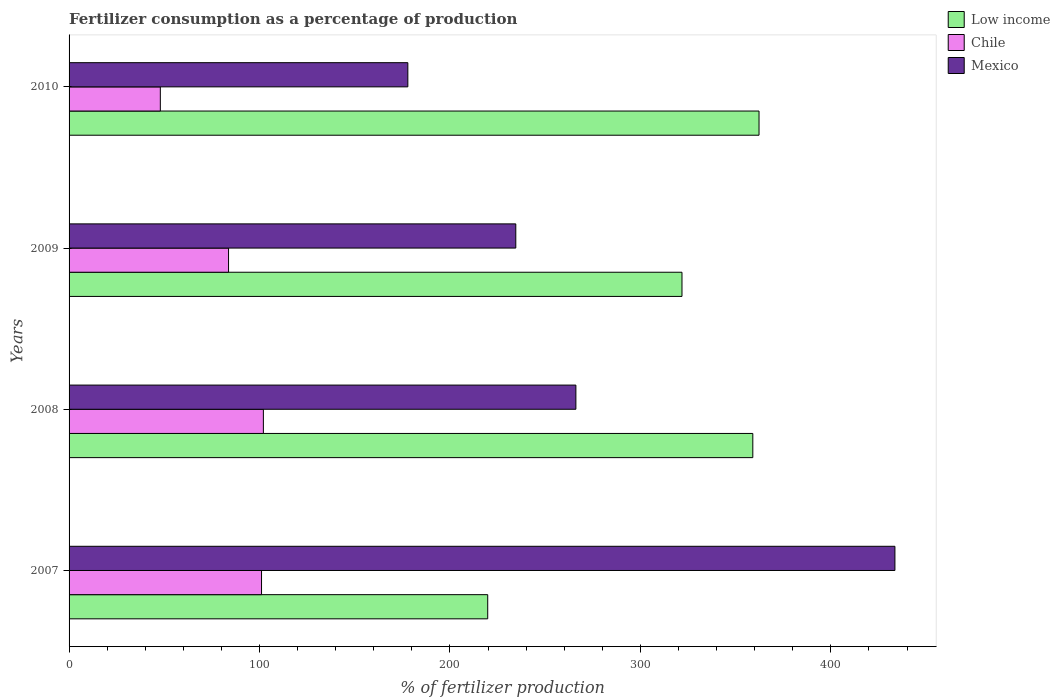How many different coloured bars are there?
Your answer should be very brief. 3. Are the number of bars per tick equal to the number of legend labels?
Provide a succinct answer. Yes. How many bars are there on the 2nd tick from the top?
Keep it short and to the point. 3. In how many cases, is the number of bars for a given year not equal to the number of legend labels?
Your answer should be very brief. 0. What is the percentage of fertilizers consumed in Mexico in 2008?
Provide a succinct answer. 266.11. Across all years, what is the maximum percentage of fertilizers consumed in Mexico?
Give a very brief answer. 433.62. Across all years, what is the minimum percentage of fertilizers consumed in Chile?
Make the answer very short. 47.92. In which year was the percentage of fertilizers consumed in Low income minimum?
Ensure brevity in your answer.  2007. What is the total percentage of fertilizers consumed in Chile in the graph?
Provide a short and direct response. 334.73. What is the difference between the percentage of fertilizers consumed in Low income in 2009 and that in 2010?
Your response must be concise. -40.45. What is the difference between the percentage of fertilizers consumed in Mexico in 2009 and the percentage of fertilizers consumed in Low income in 2008?
Your response must be concise. -124.45. What is the average percentage of fertilizers consumed in Low income per year?
Your answer should be compact. 315.73. In the year 2008, what is the difference between the percentage of fertilizers consumed in Chile and percentage of fertilizers consumed in Mexico?
Your response must be concise. -164.09. In how many years, is the percentage of fertilizers consumed in Low income greater than 180 %?
Provide a short and direct response. 4. What is the ratio of the percentage of fertilizers consumed in Chile in 2007 to that in 2009?
Provide a succinct answer. 1.21. Is the difference between the percentage of fertilizers consumed in Chile in 2007 and 2009 greater than the difference between the percentage of fertilizers consumed in Mexico in 2007 and 2009?
Ensure brevity in your answer.  No. What is the difference between the highest and the second highest percentage of fertilizers consumed in Low income?
Your answer should be very brief. 3.26. What is the difference between the highest and the lowest percentage of fertilizers consumed in Low income?
Your response must be concise. 142.46. Is the sum of the percentage of fertilizers consumed in Chile in 2008 and 2009 greater than the maximum percentage of fertilizers consumed in Mexico across all years?
Your answer should be compact. No. What does the 3rd bar from the bottom in 2007 represents?
Keep it short and to the point. Mexico. How many bars are there?
Keep it short and to the point. 12. Are the values on the major ticks of X-axis written in scientific E-notation?
Make the answer very short. No. Does the graph contain any zero values?
Your answer should be very brief. No. How many legend labels are there?
Your answer should be very brief. 3. How are the legend labels stacked?
Offer a very short reply. Vertical. What is the title of the graph?
Your response must be concise. Fertilizer consumption as a percentage of production. What is the label or title of the X-axis?
Keep it short and to the point. % of fertilizer production. What is the % of fertilizer production of Low income in 2007?
Your answer should be compact. 219.81. What is the % of fertilizer production of Chile in 2007?
Keep it short and to the point. 101.06. What is the % of fertilizer production of Mexico in 2007?
Keep it short and to the point. 433.62. What is the % of fertilizer production of Low income in 2008?
Give a very brief answer. 359.01. What is the % of fertilizer production in Chile in 2008?
Offer a terse response. 102.02. What is the % of fertilizer production in Mexico in 2008?
Give a very brief answer. 266.11. What is the % of fertilizer production of Low income in 2009?
Keep it short and to the point. 321.82. What is the % of fertilizer production in Chile in 2009?
Keep it short and to the point. 83.73. What is the % of fertilizer production of Mexico in 2009?
Your answer should be compact. 234.56. What is the % of fertilizer production of Low income in 2010?
Provide a short and direct response. 362.27. What is the % of fertilizer production of Chile in 2010?
Provide a short and direct response. 47.92. What is the % of fertilizer production of Mexico in 2010?
Give a very brief answer. 177.87. Across all years, what is the maximum % of fertilizer production in Low income?
Give a very brief answer. 362.27. Across all years, what is the maximum % of fertilizer production of Chile?
Offer a terse response. 102.02. Across all years, what is the maximum % of fertilizer production of Mexico?
Keep it short and to the point. 433.62. Across all years, what is the minimum % of fertilizer production of Low income?
Your response must be concise. 219.81. Across all years, what is the minimum % of fertilizer production in Chile?
Keep it short and to the point. 47.92. Across all years, what is the minimum % of fertilizer production of Mexico?
Your answer should be compact. 177.87. What is the total % of fertilizer production in Low income in the graph?
Offer a very short reply. 1262.91. What is the total % of fertilizer production of Chile in the graph?
Ensure brevity in your answer.  334.73. What is the total % of fertilizer production in Mexico in the graph?
Provide a short and direct response. 1112.17. What is the difference between the % of fertilizer production in Low income in 2007 and that in 2008?
Give a very brief answer. -139.19. What is the difference between the % of fertilizer production in Chile in 2007 and that in 2008?
Provide a succinct answer. -0.96. What is the difference between the % of fertilizer production of Mexico in 2007 and that in 2008?
Keep it short and to the point. 167.51. What is the difference between the % of fertilizer production of Low income in 2007 and that in 2009?
Make the answer very short. -102.01. What is the difference between the % of fertilizer production of Chile in 2007 and that in 2009?
Your answer should be very brief. 17.32. What is the difference between the % of fertilizer production in Mexico in 2007 and that in 2009?
Make the answer very short. 199.06. What is the difference between the % of fertilizer production in Low income in 2007 and that in 2010?
Your response must be concise. -142.46. What is the difference between the % of fertilizer production of Chile in 2007 and that in 2010?
Give a very brief answer. 53.14. What is the difference between the % of fertilizer production of Mexico in 2007 and that in 2010?
Ensure brevity in your answer.  255.75. What is the difference between the % of fertilizer production in Low income in 2008 and that in 2009?
Keep it short and to the point. 37.19. What is the difference between the % of fertilizer production in Chile in 2008 and that in 2009?
Your response must be concise. 18.29. What is the difference between the % of fertilizer production of Mexico in 2008 and that in 2009?
Provide a short and direct response. 31.56. What is the difference between the % of fertilizer production in Low income in 2008 and that in 2010?
Offer a terse response. -3.26. What is the difference between the % of fertilizer production in Chile in 2008 and that in 2010?
Give a very brief answer. 54.1. What is the difference between the % of fertilizer production in Mexico in 2008 and that in 2010?
Your answer should be very brief. 88.24. What is the difference between the % of fertilizer production in Low income in 2009 and that in 2010?
Your answer should be compact. -40.45. What is the difference between the % of fertilizer production in Chile in 2009 and that in 2010?
Make the answer very short. 35.81. What is the difference between the % of fertilizer production in Mexico in 2009 and that in 2010?
Keep it short and to the point. 56.68. What is the difference between the % of fertilizer production of Low income in 2007 and the % of fertilizer production of Chile in 2008?
Your answer should be very brief. 117.79. What is the difference between the % of fertilizer production in Low income in 2007 and the % of fertilizer production in Mexico in 2008?
Offer a terse response. -46.3. What is the difference between the % of fertilizer production of Chile in 2007 and the % of fertilizer production of Mexico in 2008?
Ensure brevity in your answer.  -165.06. What is the difference between the % of fertilizer production of Low income in 2007 and the % of fertilizer production of Chile in 2009?
Offer a terse response. 136.08. What is the difference between the % of fertilizer production of Low income in 2007 and the % of fertilizer production of Mexico in 2009?
Your answer should be compact. -14.74. What is the difference between the % of fertilizer production in Chile in 2007 and the % of fertilizer production in Mexico in 2009?
Your answer should be compact. -133.5. What is the difference between the % of fertilizer production in Low income in 2007 and the % of fertilizer production in Chile in 2010?
Your response must be concise. 171.89. What is the difference between the % of fertilizer production in Low income in 2007 and the % of fertilizer production in Mexico in 2010?
Your answer should be compact. 41.94. What is the difference between the % of fertilizer production in Chile in 2007 and the % of fertilizer production in Mexico in 2010?
Provide a succinct answer. -76.82. What is the difference between the % of fertilizer production in Low income in 2008 and the % of fertilizer production in Chile in 2009?
Provide a succinct answer. 275.27. What is the difference between the % of fertilizer production in Low income in 2008 and the % of fertilizer production in Mexico in 2009?
Provide a succinct answer. 124.45. What is the difference between the % of fertilizer production in Chile in 2008 and the % of fertilizer production in Mexico in 2009?
Your response must be concise. -132.54. What is the difference between the % of fertilizer production of Low income in 2008 and the % of fertilizer production of Chile in 2010?
Provide a short and direct response. 311.09. What is the difference between the % of fertilizer production of Low income in 2008 and the % of fertilizer production of Mexico in 2010?
Provide a short and direct response. 181.13. What is the difference between the % of fertilizer production of Chile in 2008 and the % of fertilizer production of Mexico in 2010?
Provide a succinct answer. -75.85. What is the difference between the % of fertilizer production in Low income in 2009 and the % of fertilizer production in Chile in 2010?
Provide a succinct answer. 273.9. What is the difference between the % of fertilizer production of Low income in 2009 and the % of fertilizer production of Mexico in 2010?
Keep it short and to the point. 143.95. What is the difference between the % of fertilizer production in Chile in 2009 and the % of fertilizer production in Mexico in 2010?
Offer a terse response. -94.14. What is the average % of fertilizer production of Low income per year?
Your response must be concise. 315.73. What is the average % of fertilizer production of Chile per year?
Provide a succinct answer. 83.68. What is the average % of fertilizer production of Mexico per year?
Provide a short and direct response. 278.04. In the year 2007, what is the difference between the % of fertilizer production of Low income and % of fertilizer production of Chile?
Give a very brief answer. 118.76. In the year 2007, what is the difference between the % of fertilizer production in Low income and % of fertilizer production in Mexico?
Keep it short and to the point. -213.81. In the year 2007, what is the difference between the % of fertilizer production of Chile and % of fertilizer production of Mexico?
Provide a succinct answer. -332.57. In the year 2008, what is the difference between the % of fertilizer production of Low income and % of fertilizer production of Chile?
Provide a succinct answer. 256.99. In the year 2008, what is the difference between the % of fertilizer production of Low income and % of fertilizer production of Mexico?
Provide a succinct answer. 92.89. In the year 2008, what is the difference between the % of fertilizer production in Chile and % of fertilizer production in Mexico?
Your response must be concise. -164.09. In the year 2009, what is the difference between the % of fertilizer production of Low income and % of fertilizer production of Chile?
Ensure brevity in your answer.  238.09. In the year 2009, what is the difference between the % of fertilizer production of Low income and % of fertilizer production of Mexico?
Provide a succinct answer. 87.26. In the year 2009, what is the difference between the % of fertilizer production in Chile and % of fertilizer production in Mexico?
Your answer should be compact. -150.82. In the year 2010, what is the difference between the % of fertilizer production of Low income and % of fertilizer production of Chile?
Your answer should be very brief. 314.35. In the year 2010, what is the difference between the % of fertilizer production of Low income and % of fertilizer production of Mexico?
Keep it short and to the point. 184.4. In the year 2010, what is the difference between the % of fertilizer production in Chile and % of fertilizer production in Mexico?
Your answer should be compact. -129.96. What is the ratio of the % of fertilizer production in Low income in 2007 to that in 2008?
Keep it short and to the point. 0.61. What is the ratio of the % of fertilizer production in Mexico in 2007 to that in 2008?
Keep it short and to the point. 1.63. What is the ratio of the % of fertilizer production in Low income in 2007 to that in 2009?
Offer a terse response. 0.68. What is the ratio of the % of fertilizer production of Chile in 2007 to that in 2009?
Ensure brevity in your answer.  1.21. What is the ratio of the % of fertilizer production of Mexico in 2007 to that in 2009?
Your answer should be compact. 1.85. What is the ratio of the % of fertilizer production in Low income in 2007 to that in 2010?
Offer a terse response. 0.61. What is the ratio of the % of fertilizer production of Chile in 2007 to that in 2010?
Ensure brevity in your answer.  2.11. What is the ratio of the % of fertilizer production in Mexico in 2007 to that in 2010?
Offer a very short reply. 2.44. What is the ratio of the % of fertilizer production of Low income in 2008 to that in 2009?
Provide a short and direct response. 1.12. What is the ratio of the % of fertilizer production in Chile in 2008 to that in 2009?
Provide a short and direct response. 1.22. What is the ratio of the % of fertilizer production in Mexico in 2008 to that in 2009?
Ensure brevity in your answer.  1.13. What is the ratio of the % of fertilizer production in Low income in 2008 to that in 2010?
Provide a short and direct response. 0.99. What is the ratio of the % of fertilizer production of Chile in 2008 to that in 2010?
Your response must be concise. 2.13. What is the ratio of the % of fertilizer production in Mexico in 2008 to that in 2010?
Provide a succinct answer. 1.5. What is the ratio of the % of fertilizer production in Low income in 2009 to that in 2010?
Give a very brief answer. 0.89. What is the ratio of the % of fertilizer production of Chile in 2009 to that in 2010?
Ensure brevity in your answer.  1.75. What is the ratio of the % of fertilizer production of Mexico in 2009 to that in 2010?
Your answer should be compact. 1.32. What is the difference between the highest and the second highest % of fertilizer production in Low income?
Ensure brevity in your answer.  3.26. What is the difference between the highest and the second highest % of fertilizer production in Chile?
Ensure brevity in your answer.  0.96. What is the difference between the highest and the second highest % of fertilizer production of Mexico?
Give a very brief answer. 167.51. What is the difference between the highest and the lowest % of fertilizer production of Low income?
Make the answer very short. 142.46. What is the difference between the highest and the lowest % of fertilizer production of Chile?
Your answer should be compact. 54.1. What is the difference between the highest and the lowest % of fertilizer production of Mexico?
Give a very brief answer. 255.75. 